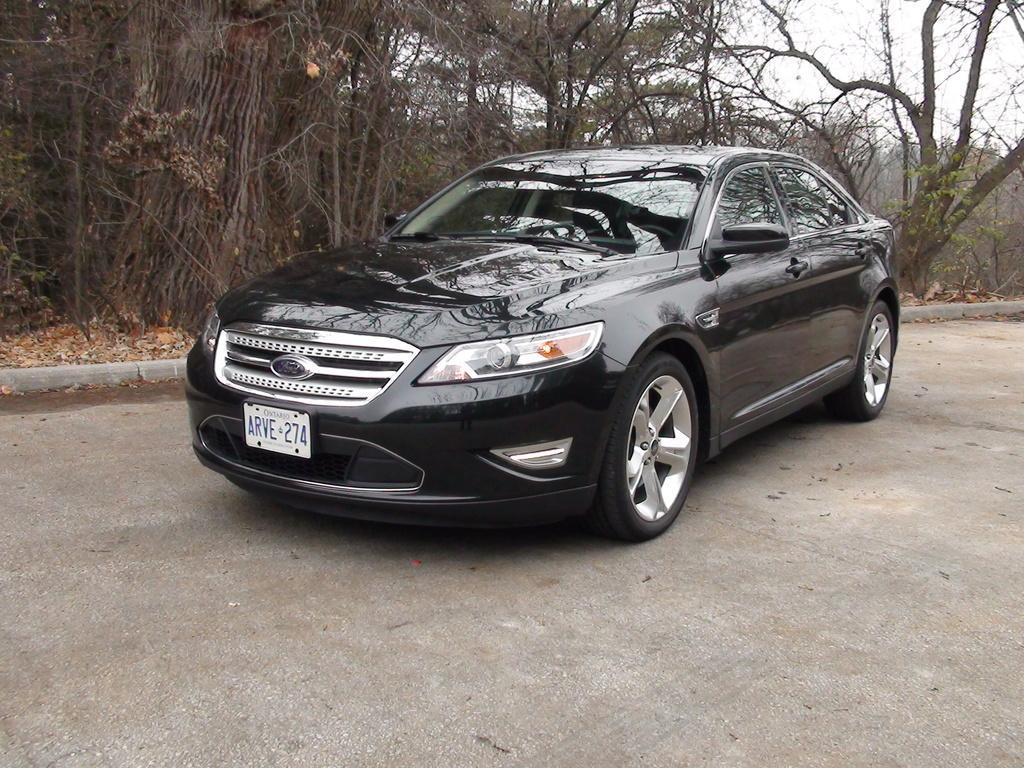Could you give a brief overview of what you see in this image? In this image I see the path and I see a car over here which is of black in color and I see the number plate over here on which there are alphabets and numbers written. In the background I see number of trees and I see the sky. 